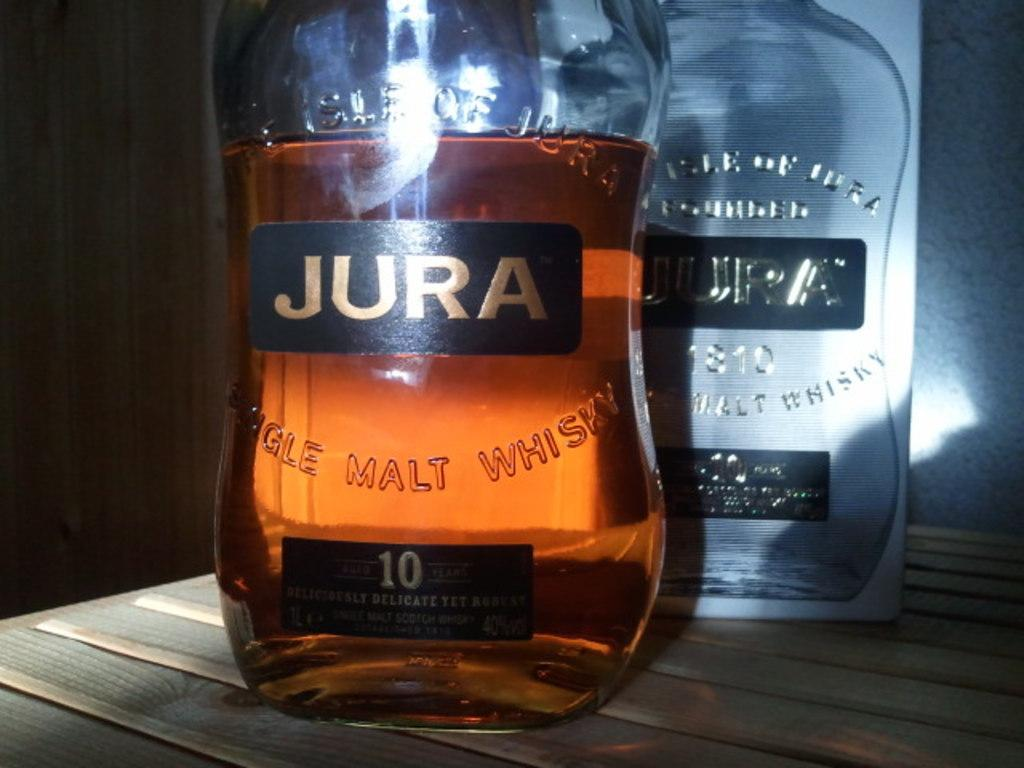<image>
Describe the image concisely. A two bottles of different kinds of Jura whiskey. 